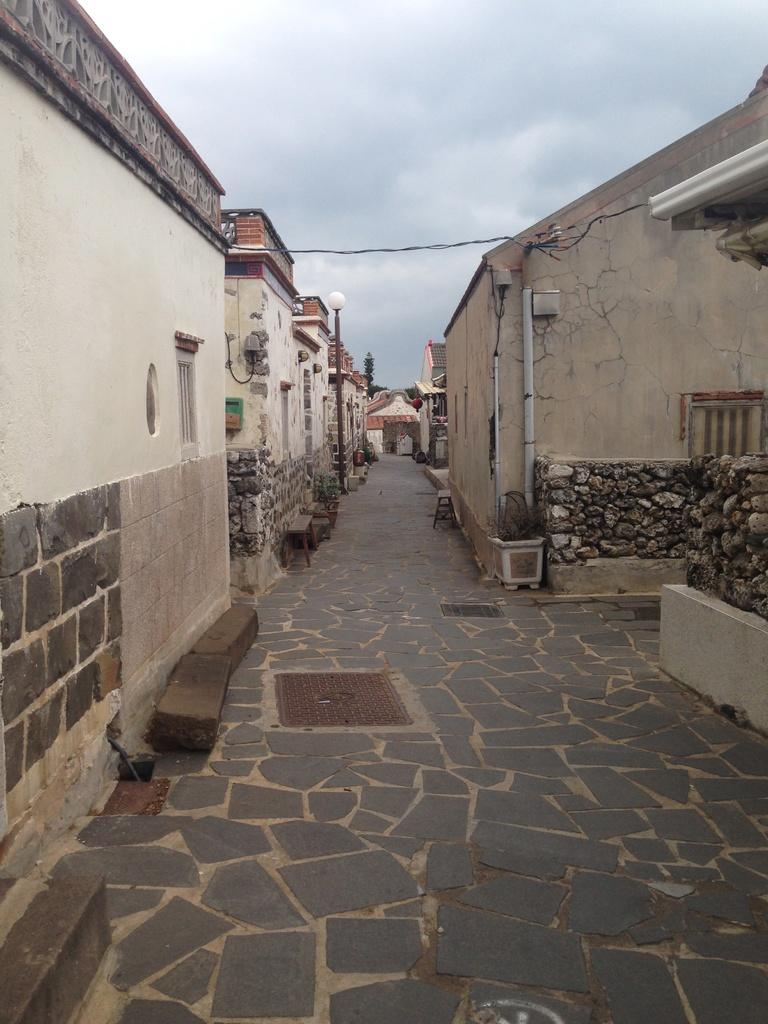What type of structures can be seen in the image? There are houses in the image. What other objects are present in the image? There are poles and benches in the image. What can be seen in the sky at the top of the image? There are clouds visible in the sky at the top of the image. Where is the lunchroom located in the image? There is no lunchroom present in the image. What type of nut is being used to hold the poles together in the image? There are no nuts visible in the image, and the poles are not being held together by any visible means. 